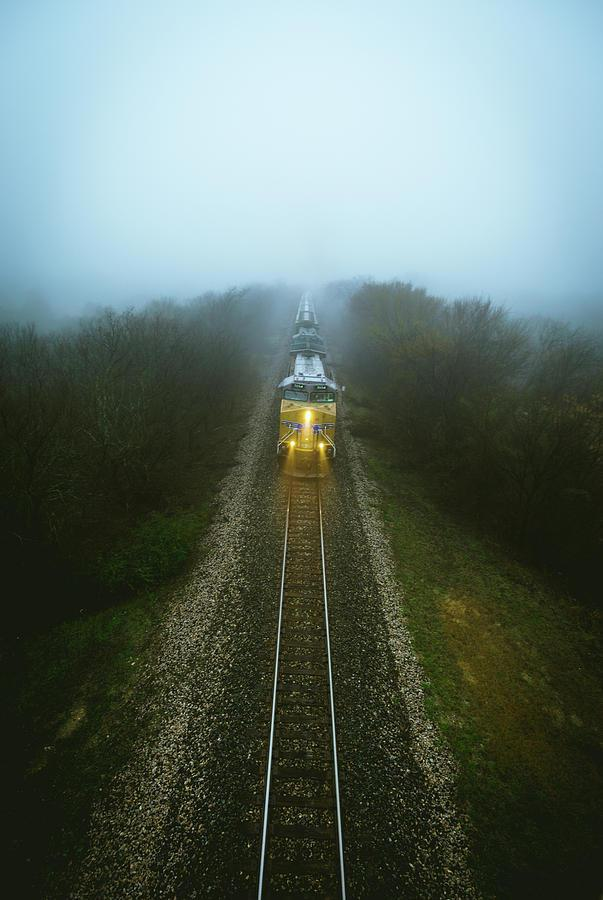What time of day does this image appear to be taken? The image seems to be taken during the day, given the available light, but the exact time is obscured by the fog. The diffused lighting suggests it could be morning. 